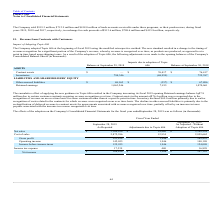According to Plexus's financial document, How did the company adopt Topic 606 at the beginning of Fiscal 2019? using the modified retrospective method. The document states: "adopted Topic 606 at the beginning of fiscal 2019 using the modified retrospective method. The new standard resulted in a change to the timing of reve..." Also, What was the balance of contract assets after the adoption of Topic 606? According to the financial document, 76,417 (in thousands). The relevant text states: "Contract assets $ — $ 76,417 $ 76,417..." Also, What was the balance of Inventories before adoption of Topic 606? According to the financial document, 794,346 (in thousands). The relevant text states: "Inventories 794,346 (68,959) 725,387..." Also, How many assets and liabilities had an end balance at September 30, 2019 that exceeded $1,000,000 thousand? Based on the analysis, there are 1 instances. The counting process: Retained earnings. Also, can you calculate: What was the difference between the impacts due to adoption of Topic 606 between Contract assets and inventories? Based on the calculation: 76,417-(-68,959), the result is 145376 (in thousands). This is based on the information: "Inventories 794,346 (68,959) 725,387 Contract assets $ — $ 76,417 $ 76,417..." The key data points involved are: 68,959, 76,417. Also, can you calculate: What was the percentage change in other accrued liabilities between before and after the impact of Topic 606? To answer this question, I need to perform calculations using the financial data. The calculation is: (67,806-68,163)/68,163, which equals -0.52 (percentage). This is based on the information: "UITY Other accrued liabilities $ 68,163 $ (357) $ 67,806 SHAREHOLDERS' EQUITY Other accrued liabilities $ 68,163 $ (357) $ 67,806..." The key data points involved are: 67,806, 68,163. 